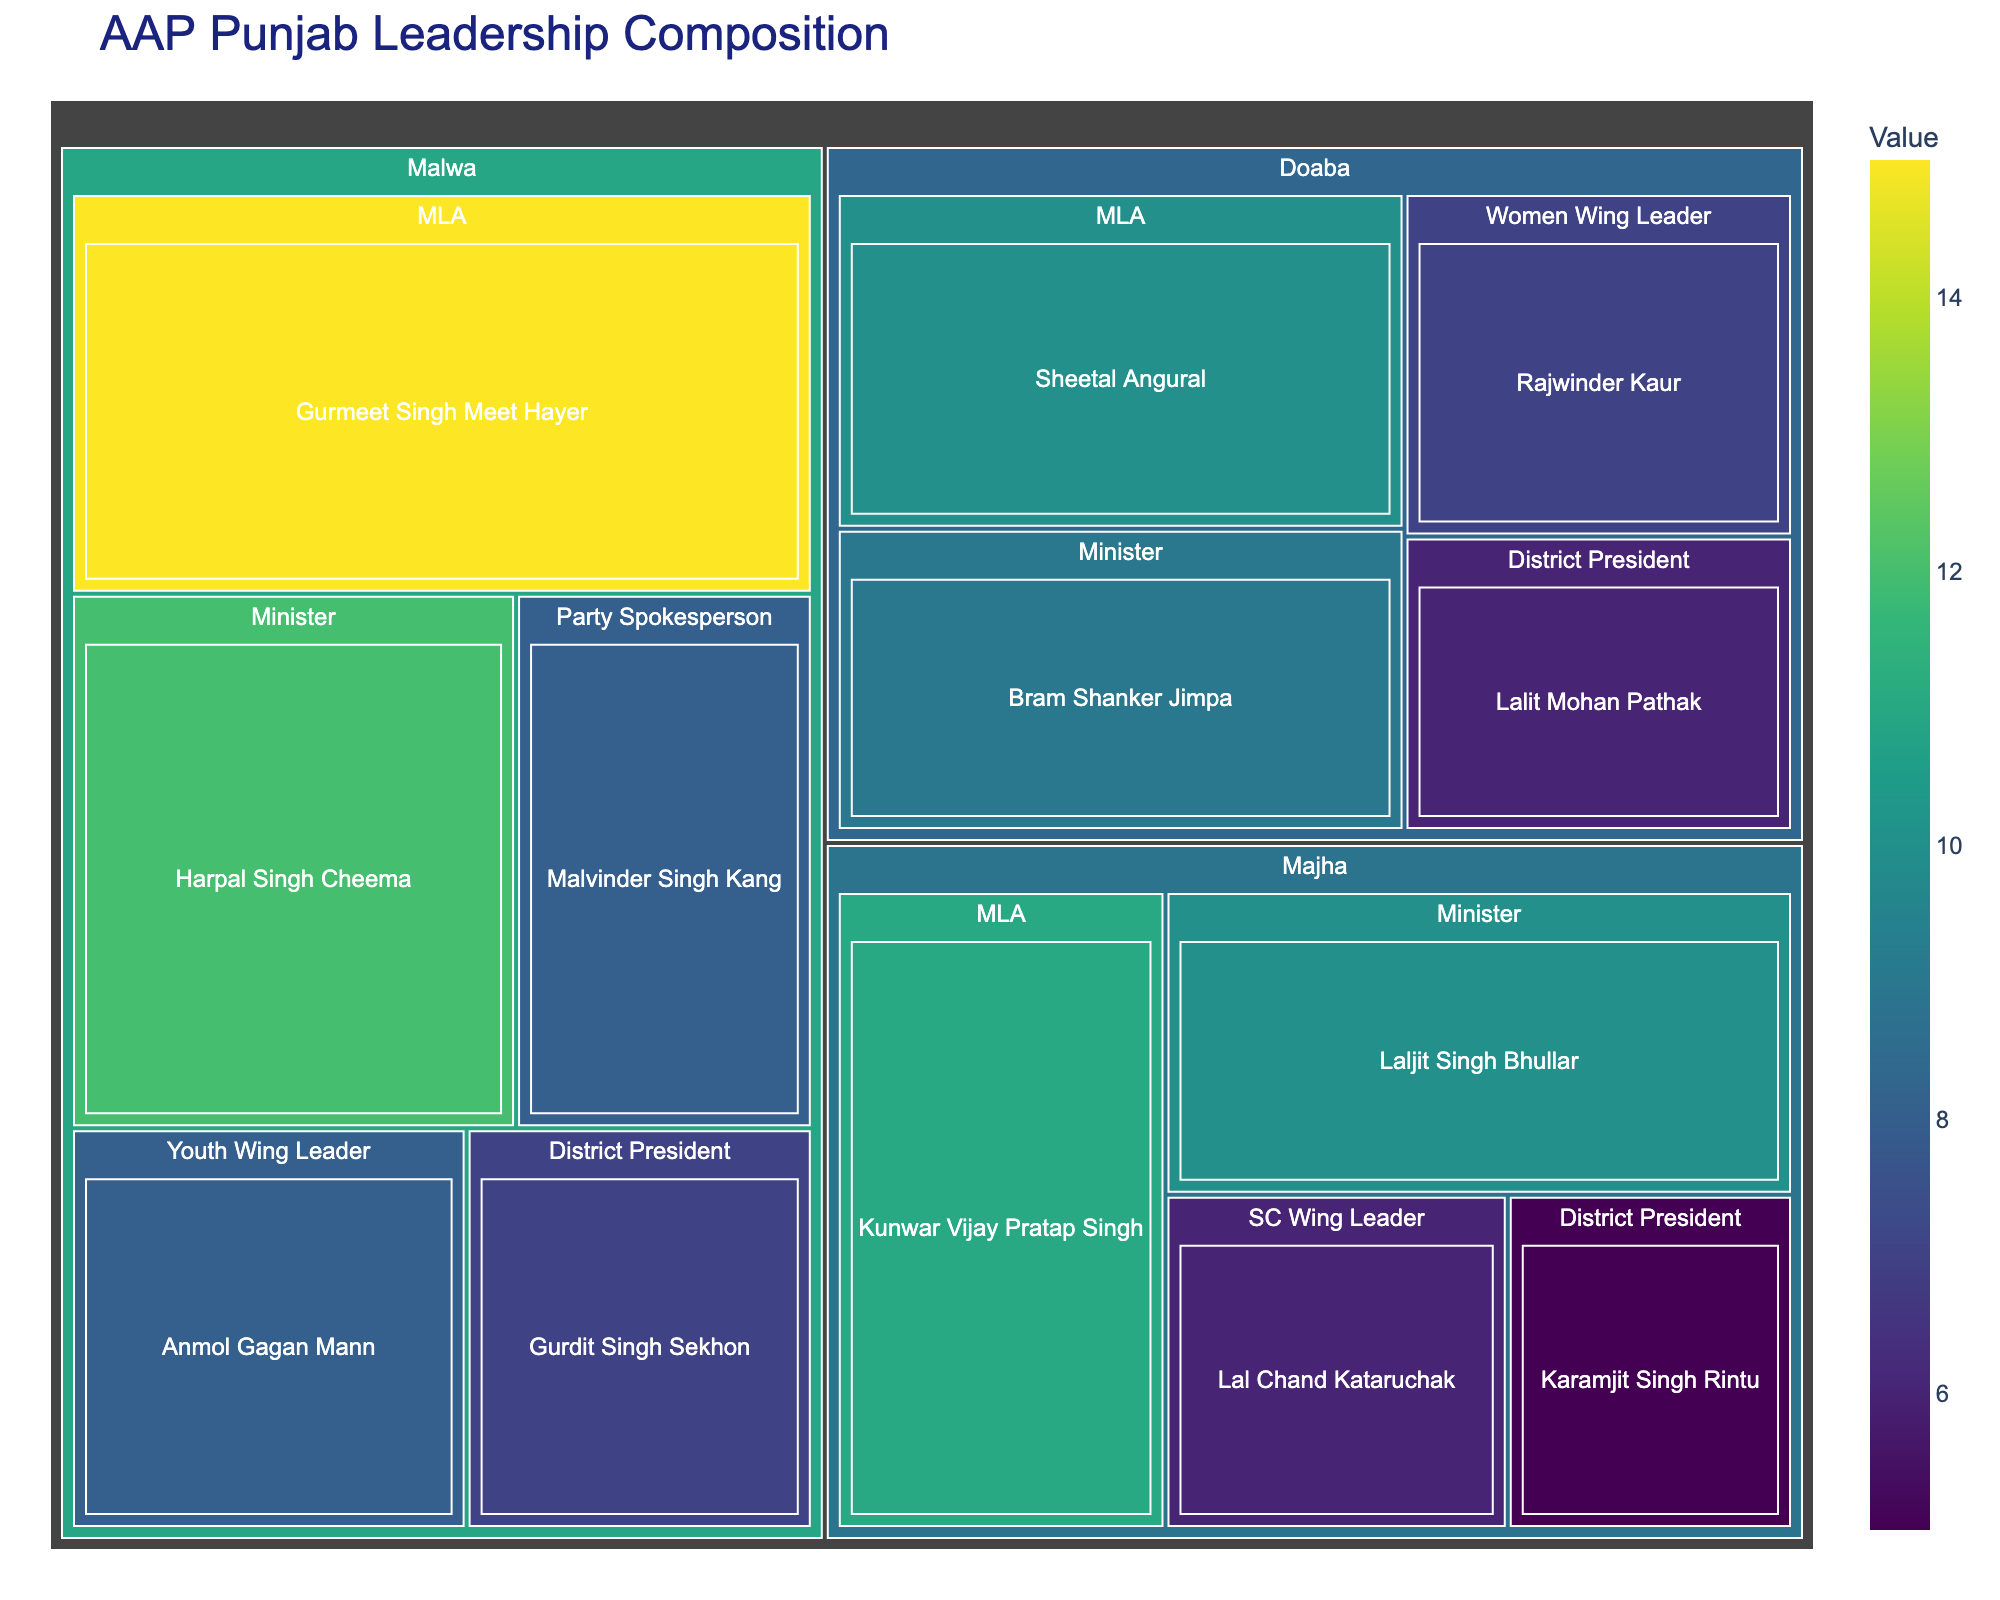Who has the highest value among the Malwa ministers? Look for the segment labeled 'Minister' under the 'Malwa' region, then identify the person with the highest value. Harpal Singh Cheema has a value of 12, which is the highest among the Malwa ministers.
Answer: Harpal Singh Cheema What is the total value of all the MLAs in the Doaba region? Look for all segments labeled 'MLA' under the 'Doaba' region. Sum the values of these segments: Sheetal Angural (10).
Answer: 10 Which region has the highest total value for 'District President' roles? Inspect each region for 'District President' roles, sum their values, and compare. Malwa has 7, Doaba has 6, and Majha has 5. The highest is Malwa with 7.
Answer: Malwa Compare the value of Anmol Gagan Mann with Sheetal Angural. Who has a higher value and by how much? Identify the values for Anmol Gagan Mann (8) and Sheetal Angural (10). Subtract Anmol Gagan Mann's value from Sheetal Angural's: 10 - 8 = 2. Therefore, Sheetal Angural has a higher value by 2.
Answer: Sheetal Angural, by 2 What is the average value of the ministers across all regions? Add the values of all the ministers: Harpal Singh Cheema (12), Bram Shanker Jimpa (9), and Laljit Singh Bhullar (10). There are 3 ministers. The sum is 31, so the average is 31/3 ≈ 10.33.
Answer: 10.33 Which role in the Majha region has the lowest value? Look for all roles under the 'Majha' region and identify the one with the lowest value: MLA (11), Minister (10), District President (5), SC Wing Leader (6). The lowest is 'District President' with a value of 5.
Answer: District President How many distinct roles are represented in the Malwa region? Identify unique roles under 'Malwa': MLA, Minister, Party Spokesperson, District President, Youth Wing Leader. Count the distinct roles.
Answer: 5 What is the combined value for all roles related to women in the figure? Identify all roles related to women: Women Wing Leader (Doaba: Rajwinder Kaur, 7) and Youth Wing Leader (Malwa: Anmol Gagan Mann, 8). Sum their values: 7 + 8 = 15.
Answer: 15 Compare the total values of the Doaba and Majha regions. Which region has a higher total value? Sum the values of all segments in the Doaba region: 10 + 9 + 6 + 7 = 32. Sum the values of all segments in the Majha region: 11 + 10 + 5 + 6 = 32. Both regions have the same total value.
Answer: Both regions are equal at 32 